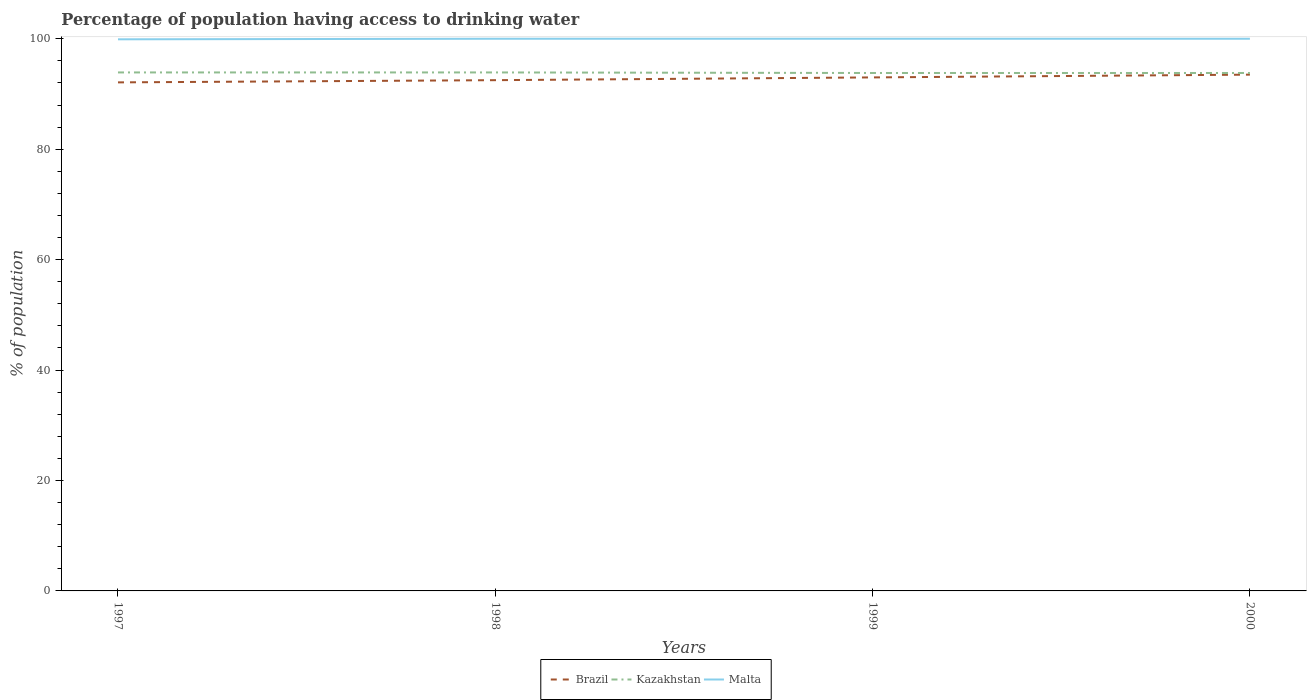Across all years, what is the maximum percentage of population having access to drinking water in Malta?
Provide a short and direct response. 99.9. In which year was the percentage of population having access to drinking water in Brazil maximum?
Keep it short and to the point. 1997. What is the total percentage of population having access to drinking water in Kazakhstan in the graph?
Give a very brief answer. 0.1. What is the difference between the highest and the second highest percentage of population having access to drinking water in Brazil?
Ensure brevity in your answer.  1.4. What is the difference between the highest and the lowest percentage of population having access to drinking water in Kazakhstan?
Give a very brief answer. 2. Is the percentage of population having access to drinking water in Malta strictly greater than the percentage of population having access to drinking water in Kazakhstan over the years?
Provide a succinct answer. No. How many lines are there?
Your response must be concise. 3. What is the difference between two consecutive major ticks on the Y-axis?
Make the answer very short. 20. Does the graph contain any zero values?
Keep it short and to the point. No. Does the graph contain grids?
Make the answer very short. No. Where does the legend appear in the graph?
Provide a short and direct response. Bottom center. How are the legend labels stacked?
Offer a terse response. Horizontal. What is the title of the graph?
Give a very brief answer. Percentage of population having access to drinking water. What is the label or title of the Y-axis?
Your answer should be very brief. % of population. What is the % of population in Brazil in 1997?
Provide a short and direct response. 92.1. What is the % of population in Kazakhstan in 1997?
Keep it short and to the point. 93.9. What is the % of population of Malta in 1997?
Make the answer very short. 99.9. What is the % of population in Brazil in 1998?
Offer a very short reply. 92.5. What is the % of population of Kazakhstan in 1998?
Your response must be concise. 93.9. What is the % of population in Brazil in 1999?
Keep it short and to the point. 93. What is the % of population in Kazakhstan in 1999?
Provide a short and direct response. 93.8. What is the % of population of Malta in 1999?
Your answer should be very brief. 100. What is the % of population of Brazil in 2000?
Provide a succinct answer. 93.5. What is the % of population of Kazakhstan in 2000?
Keep it short and to the point. 93.8. Across all years, what is the maximum % of population in Brazil?
Offer a terse response. 93.5. Across all years, what is the maximum % of population in Kazakhstan?
Ensure brevity in your answer.  93.9. Across all years, what is the minimum % of population of Brazil?
Your response must be concise. 92.1. Across all years, what is the minimum % of population of Kazakhstan?
Offer a very short reply. 93.8. Across all years, what is the minimum % of population of Malta?
Offer a terse response. 99.9. What is the total % of population in Brazil in the graph?
Keep it short and to the point. 371.1. What is the total % of population of Kazakhstan in the graph?
Keep it short and to the point. 375.4. What is the total % of population of Malta in the graph?
Provide a succinct answer. 399.9. What is the difference between the % of population of Brazil in 1997 and that in 1998?
Provide a short and direct response. -0.4. What is the difference between the % of population of Kazakhstan in 1997 and that in 1998?
Offer a very short reply. 0. What is the difference between the % of population in Malta in 1997 and that in 1998?
Give a very brief answer. -0.1. What is the difference between the % of population in Malta in 1997 and that in 1999?
Provide a short and direct response. -0.1. What is the difference between the % of population of Brazil in 1998 and that in 1999?
Your answer should be very brief. -0.5. What is the difference between the % of population in Malta in 1998 and that in 2000?
Provide a short and direct response. 0. What is the difference between the % of population of Brazil in 1999 and that in 2000?
Offer a very short reply. -0.5. What is the difference between the % of population in Kazakhstan in 1999 and that in 2000?
Your response must be concise. 0. What is the difference between the % of population of Malta in 1999 and that in 2000?
Offer a very short reply. 0. What is the difference between the % of population in Brazil in 1997 and the % of population in Malta in 1998?
Your answer should be compact. -7.9. What is the difference between the % of population in Brazil in 1997 and the % of population in Malta in 1999?
Keep it short and to the point. -7.9. What is the difference between the % of population in Brazil in 1997 and the % of population in Kazakhstan in 2000?
Ensure brevity in your answer.  -1.7. What is the difference between the % of population in Brazil in 1998 and the % of population in Kazakhstan in 1999?
Your answer should be very brief. -1.3. What is the difference between the % of population in Kazakhstan in 1998 and the % of population in Malta in 1999?
Provide a short and direct response. -6.1. What is the difference between the % of population in Kazakhstan in 1998 and the % of population in Malta in 2000?
Your answer should be very brief. -6.1. What is the difference between the % of population of Brazil in 1999 and the % of population of Malta in 2000?
Provide a succinct answer. -7. What is the average % of population of Brazil per year?
Your answer should be compact. 92.78. What is the average % of population in Kazakhstan per year?
Provide a short and direct response. 93.85. What is the average % of population of Malta per year?
Make the answer very short. 99.97. In the year 1997, what is the difference between the % of population in Kazakhstan and % of population in Malta?
Give a very brief answer. -6. In the year 1999, what is the difference between the % of population of Brazil and % of population of Kazakhstan?
Give a very brief answer. -0.8. In the year 1999, what is the difference between the % of population of Kazakhstan and % of population of Malta?
Your answer should be compact. -6.2. In the year 2000, what is the difference between the % of population of Brazil and % of population of Malta?
Provide a short and direct response. -6.5. What is the ratio of the % of population in Brazil in 1997 to that in 1998?
Ensure brevity in your answer.  1. What is the ratio of the % of population in Brazil in 1997 to that in 1999?
Give a very brief answer. 0.99. What is the ratio of the % of population of Malta in 1997 to that in 1999?
Make the answer very short. 1. What is the ratio of the % of population in Brazil in 1997 to that in 2000?
Ensure brevity in your answer.  0.98. What is the ratio of the % of population of Kazakhstan in 1997 to that in 2000?
Your answer should be very brief. 1. What is the ratio of the % of population of Brazil in 1998 to that in 1999?
Provide a succinct answer. 0.99. What is the ratio of the % of population of Malta in 1998 to that in 1999?
Offer a terse response. 1. What is the ratio of the % of population of Brazil in 1998 to that in 2000?
Ensure brevity in your answer.  0.99. What is the ratio of the % of population in Malta in 1998 to that in 2000?
Provide a short and direct response. 1. What is the ratio of the % of population of Kazakhstan in 1999 to that in 2000?
Ensure brevity in your answer.  1. What is the difference between the highest and the second highest % of population in Kazakhstan?
Offer a very short reply. 0. What is the difference between the highest and the second highest % of population of Malta?
Keep it short and to the point. 0. What is the difference between the highest and the lowest % of population of Kazakhstan?
Your answer should be very brief. 0.1. 